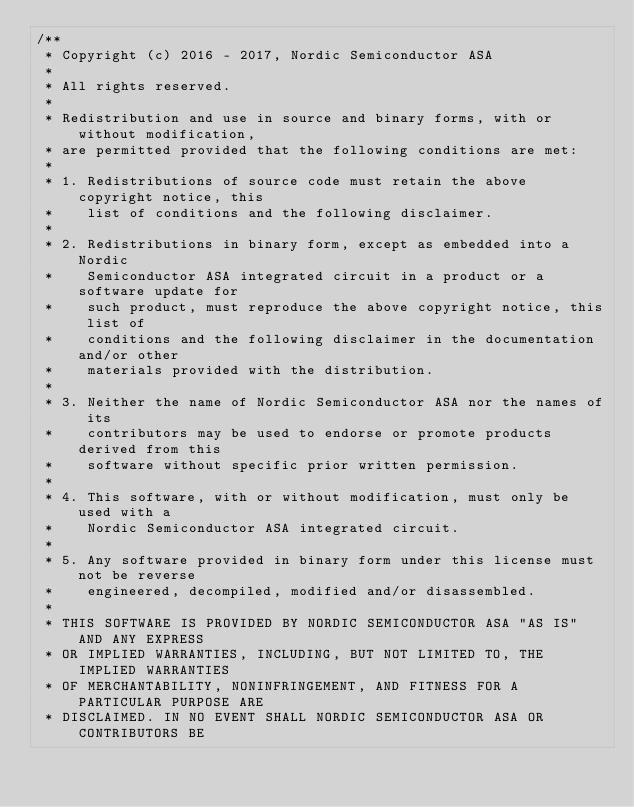Convert code to text. <code><loc_0><loc_0><loc_500><loc_500><_C_>/**
 * Copyright (c) 2016 - 2017, Nordic Semiconductor ASA
 *
 * All rights reserved.
 *
 * Redistribution and use in source and binary forms, with or without modification,
 * are permitted provided that the following conditions are met:
 *
 * 1. Redistributions of source code must retain the above copyright notice, this
 *    list of conditions and the following disclaimer.
 *
 * 2. Redistributions in binary form, except as embedded into a Nordic
 *    Semiconductor ASA integrated circuit in a product or a software update for
 *    such product, must reproduce the above copyright notice, this list of
 *    conditions and the following disclaimer in the documentation and/or other
 *    materials provided with the distribution.
 *
 * 3. Neither the name of Nordic Semiconductor ASA nor the names of its
 *    contributors may be used to endorse or promote products derived from this
 *    software without specific prior written permission.
 *
 * 4. This software, with or without modification, must only be used with a
 *    Nordic Semiconductor ASA integrated circuit.
 *
 * 5. Any software provided in binary form under this license must not be reverse
 *    engineered, decompiled, modified and/or disassembled.
 *
 * THIS SOFTWARE IS PROVIDED BY NORDIC SEMICONDUCTOR ASA "AS IS" AND ANY EXPRESS
 * OR IMPLIED WARRANTIES, INCLUDING, BUT NOT LIMITED TO, THE IMPLIED WARRANTIES
 * OF MERCHANTABILITY, NONINFRINGEMENT, AND FITNESS FOR A PARTICULAR PURPOSE ARE
 * DISCLAIMED. IN NO EVENT SHALL NORDIC SEMICONDUCTOR ASA OR CONTRIBUTORS BE</code> 